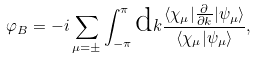Convert formula to latex. <formula><loc_0><loc_0><loc_500><loc_500>\varphi _ { B } = - i \sum _ { \mu = \pm } \int _ { - \pi } ^ { \pi } \text {d} k \frac { \langle \chi _ { \mu } | \frac { \partial } { \partial k } | \psi _ { \mu } \rangle } { \langle \chi _ { \mu } | \psi _ { \mu } \rangle } ,</formula> 